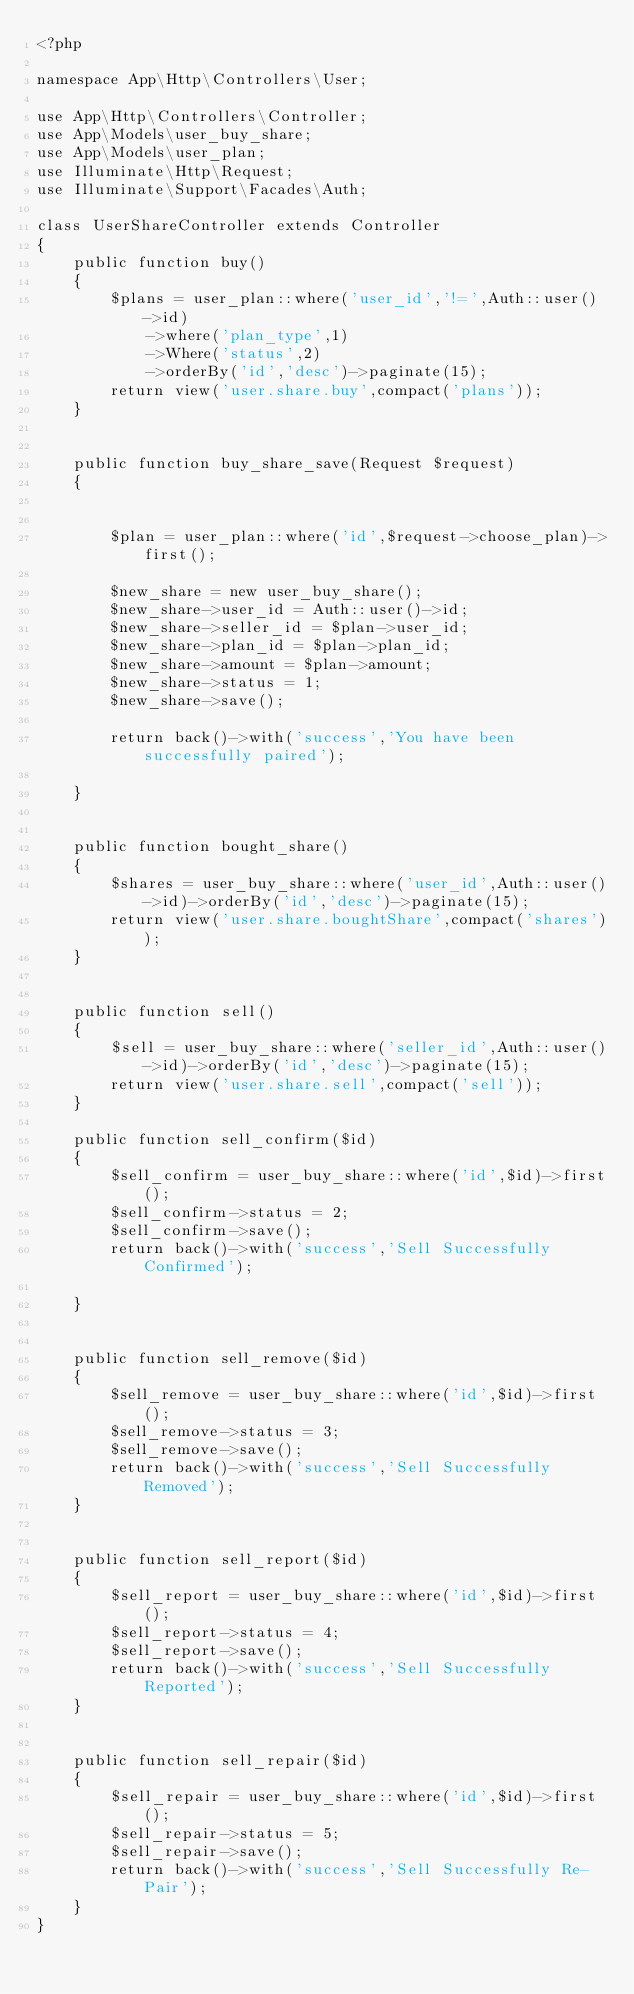<code> <loc_0><loc_0><loc_500><loc_500><_PHP_><?php

namespace App\Http\Controllers\User;

use App\Http\Controllers\Controller;
use App\Models\user_buy_share;
use App\Models\user_plan;
use Illuminate\Http\Request;
use Illuminate\Support\Facades\Auth;

class UserShareController extends Controller
{
    public function buy()
    {
        $plans = user_plan::where('user_id','!=',Auth::user()->id)
            ->where('plan_type',1)
            ->Where('status',2)
            ->orderBy('id','desc')->paginate(15);
        return view('user.share.buy',compact('plans'));
    }


    public function buy_share_save(Request $request)
    {


        $plan = user_plan::where('id',$request->choose_plan)->first();

        $new_share = new user_buy_share();
        $new_share->user_id = Auth::user()->id;
        $new_share->seller_id = $plan->user_id;
        $new_share->plan_id = $plan->plan_id;
        $new_share->amount = $plan->amount;
        $new_share->status = 1;
        $new_share->save();

        return back()->with('success','You have been successfully paired');

    }


    public function bought_share()
    {
        $shares = user_buy_share::where('user_id',Auth::user()->id)->orderBy('id','desc')->paginate(15);
        return view('user.share.boughtShare',compact('shares'));
    }


    public function sell()
    {
        $sell = user_buy_share::where('seller_id',Auth::user()->id)->orderBy('id','desc')->paginate(15);
        return view('user.share.sell',compact('sell'));
    }

    public function sell_confirm($id)
    {
        $sell_confirm = user_buy_share::where('id',$id)->first();
        $sell_confirm->status = 2;
        $sell_confirm->save();
        return back()->with('success','Sell Successfully Confirmed');

    }


    public function sell_remove($id)
    {
        $sell_remove = user_buy_share::where('id',$id)->first();
        $sell_remove->status = 3;
        $sell_remove->save();
        return back()->with('success','Sell Successfully Removed');
    }


    public function sell_report($id)
    {
        $sell_report = user_buy_share::where('id',$id)->first();
        $sell_report->status = 4;
        $sell_report->save();
        return back()->with('success','Sell Successfully Reported');
    }


    public function sell_repair($id)
    {
        $sell_repair = user_buy_share::where('id',$id)->first();
        $sell_repair->status = 5;
        $sell_repair->save();
        return back()->with('success','Sell Successfully Re-Pair');
    }
}
</code> 